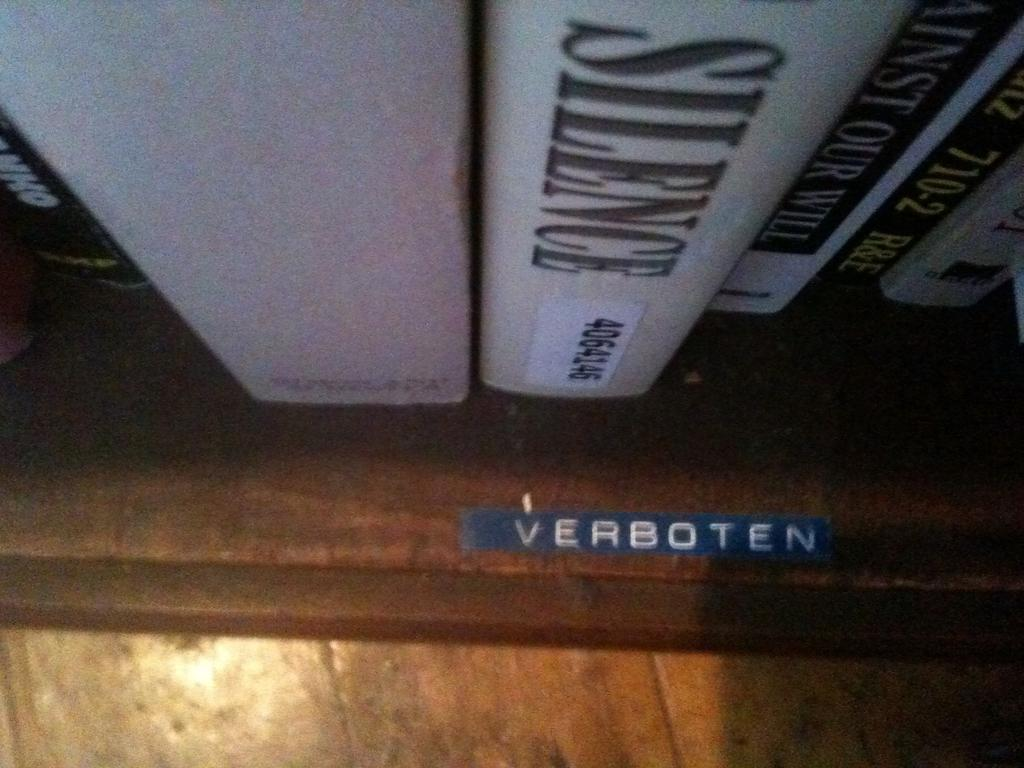Provide a one-sentence caption for the provided image. A shelf with a variety of books with a blue label on the shelf that says Verboten. 